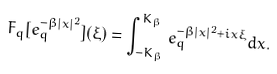Convert formula to latex. <formula><loc_0><loc_0><loc_500><loc_500>F _ { q } [ e _ { q } ^ { - \beta | x | ^ { 2 } } ] ( \xi ) = \int _ { - K _ { \beta } } ^ { K _ { \beta } } e _ { q } ^ { - \beta | x | ^ { 2 } + i x \xi } d x .</formula> 